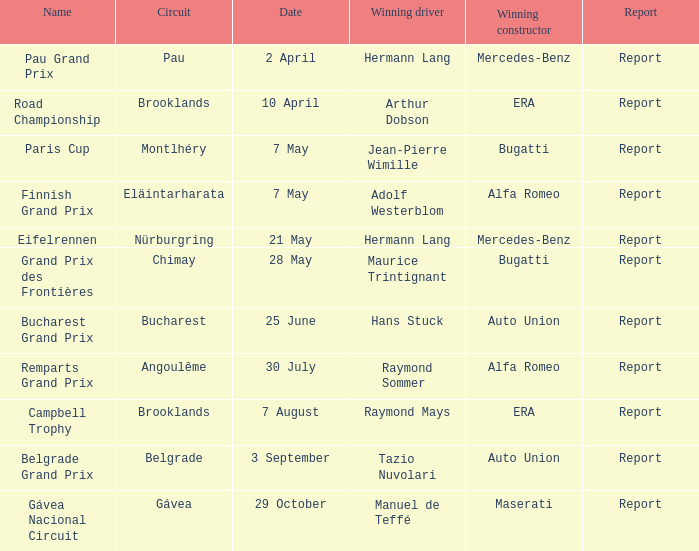What is the report for april 10th? Report. 